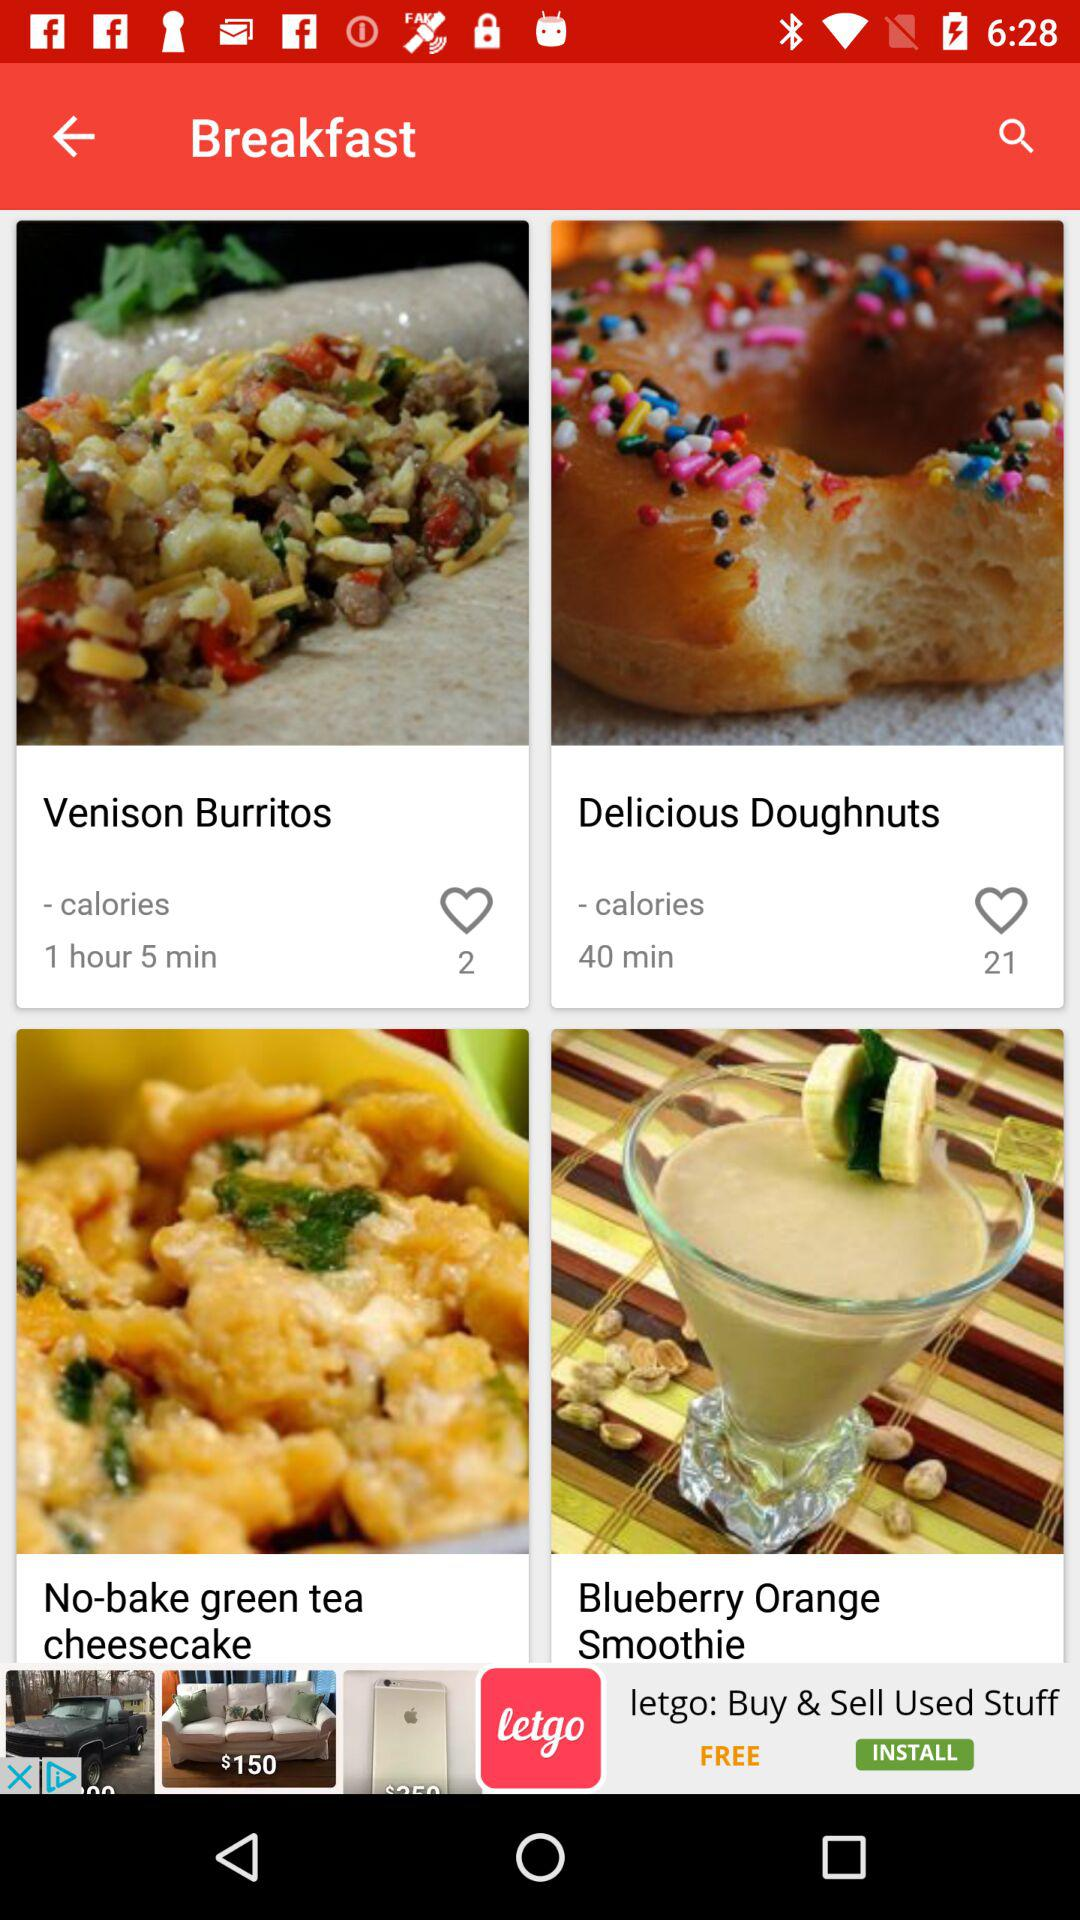What is on the breakfast menu?
Answer the question using a single word or phrase. The breakfast menu is Venison Burritos, Delicious Doughnuts, No-bake green tea cheesecake and Blueberry Orange Smoothie 